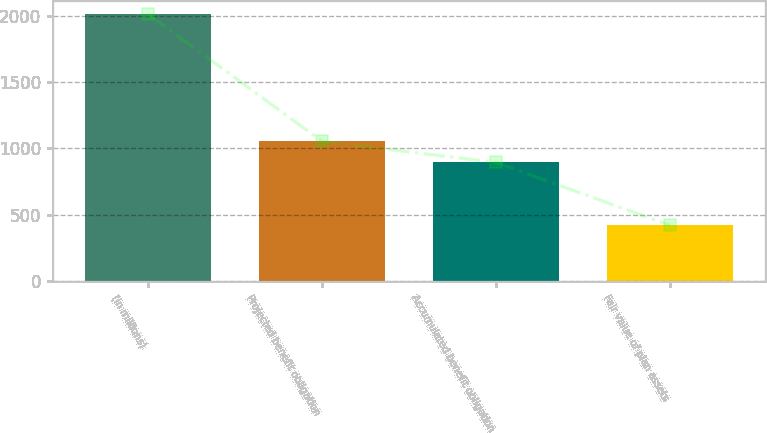Convert chart to OTSL. <chart><loc_0><loc_0><loc_500><loc_500><bar_chart><fcel>(in millions)<fcel>Projected benefit obligation<fcel>Accumulated benefit obligation<fcel>Fair value of plan assets<nl><fcel>2011<fcel>1053.9<fcel>895<fcel>422<nl></chart> 